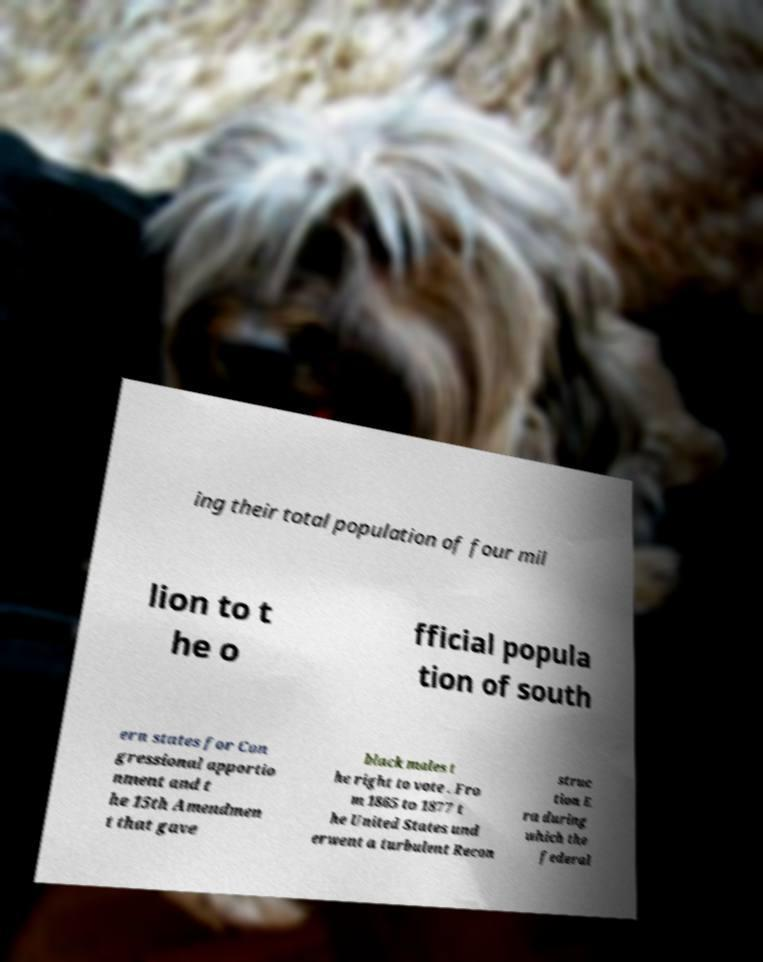I need the written content from this picture converted into text. Can you do that? ing their total population of four mil lion to t he o fficial popula tion of south ern states for Con gressional apportio nment and t he 15th Amendmen t that gave black males t he right to vote . Fro m 1865 to 1877 t he United States und erwent a turbulent Recon struc tion E ra during which the federal 